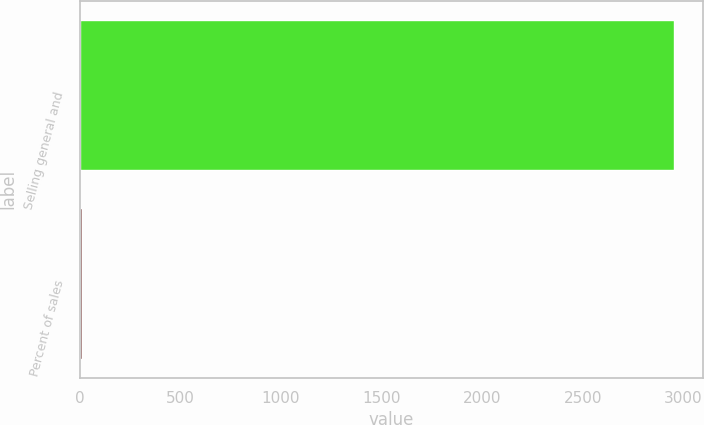Convert chart. <chart><loc_0><loc_0><loc_500><loc_500><bar_chart><fcel>Selling general and<fcel>Percent of sales<nl><fcel>2950<fcel>12.8<nl></chart> 